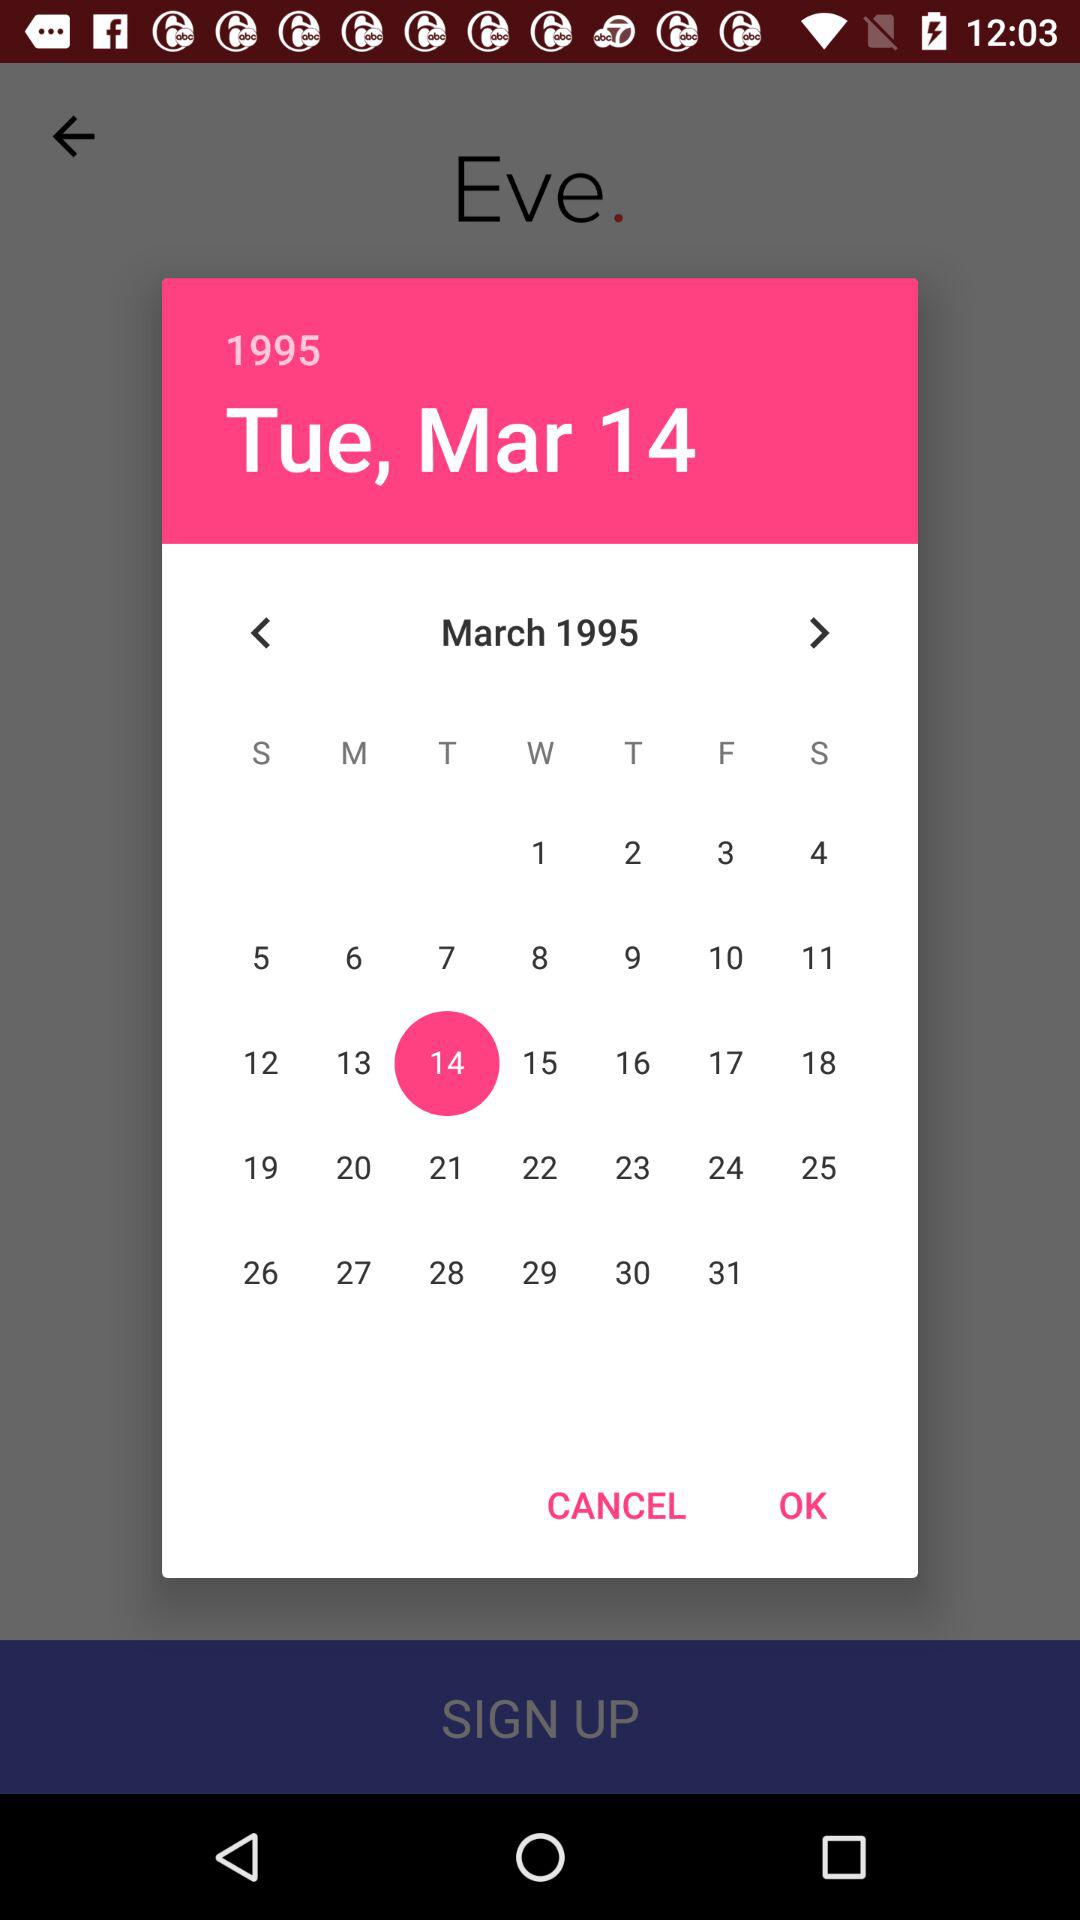What is the selected date? The selected date is Tuesday, March 14, 1995. 